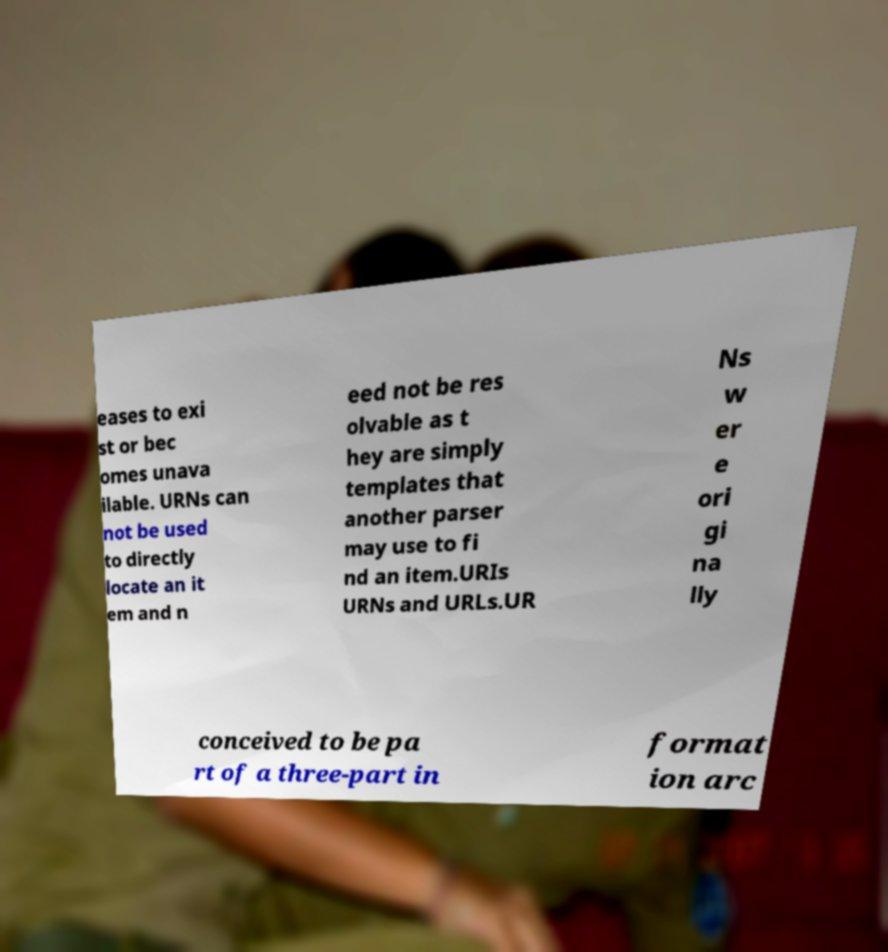Could you extract and type out the text from this image? eases to exi st or bec omes unava ilable. URNs can not be used to directly locate an it em and n eed not be res olvable as t hey are simply templates that another parser may use to fi nd an item.URIs URNs and URLs.UR Ns w er e ori gi na lly conceived to be pa rt of a three-part in format ion arc 